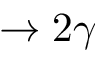<formula> <loc_0><loc_0><loc_500><loc_500>\to 2 \gamma</formula> 